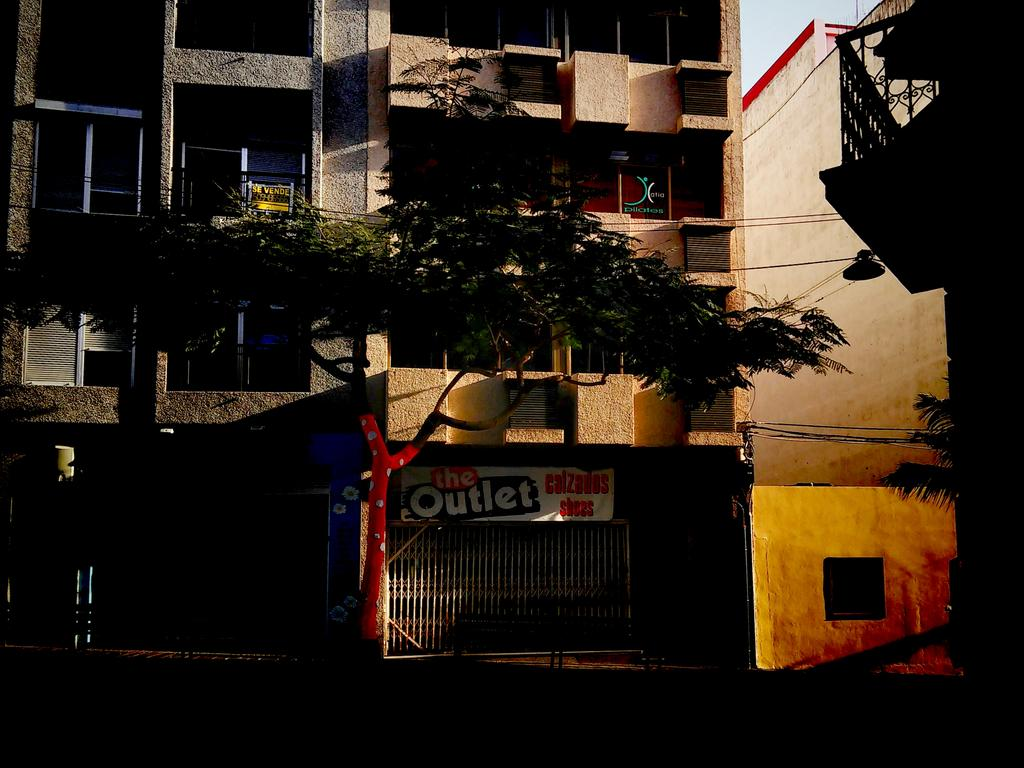What is the main structure in the center of the image? There is a building in the center of the image. What is the purpose of the gate in the image? The gate is likely used for entering or exiting the area around the building. What type of vegetation is present in the image? There is a tree in the image. What can be seen on the building in the image? There are windows visible on the building. Can you see a rat using a rake to clean the leaves around the tree in the image? There is no rat or rake present in the image; it only features a building, a gate, a tree, and windows. 